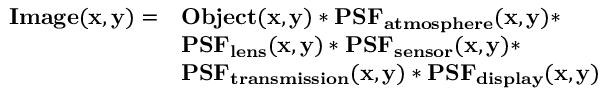<formula> <loc_0><loc_0><loc_500><loc_500>{ \begin{array} { r l } { I m a g e ( x , y ) = } & { O b j e c t ( x , y ) * P S F _ { a t m o s p h e r e } ( x , y ) * } \\ & { P S F _ { l e n s } ( x , y ) * P S F _ { s e n s o r } ( x , y ) * } \\ & { P S F _ { t r a n s m i s s i o n } ( x , y ) * P S F _ { d i s p l a y } ( x , y ) } \end{array} }</formula> 